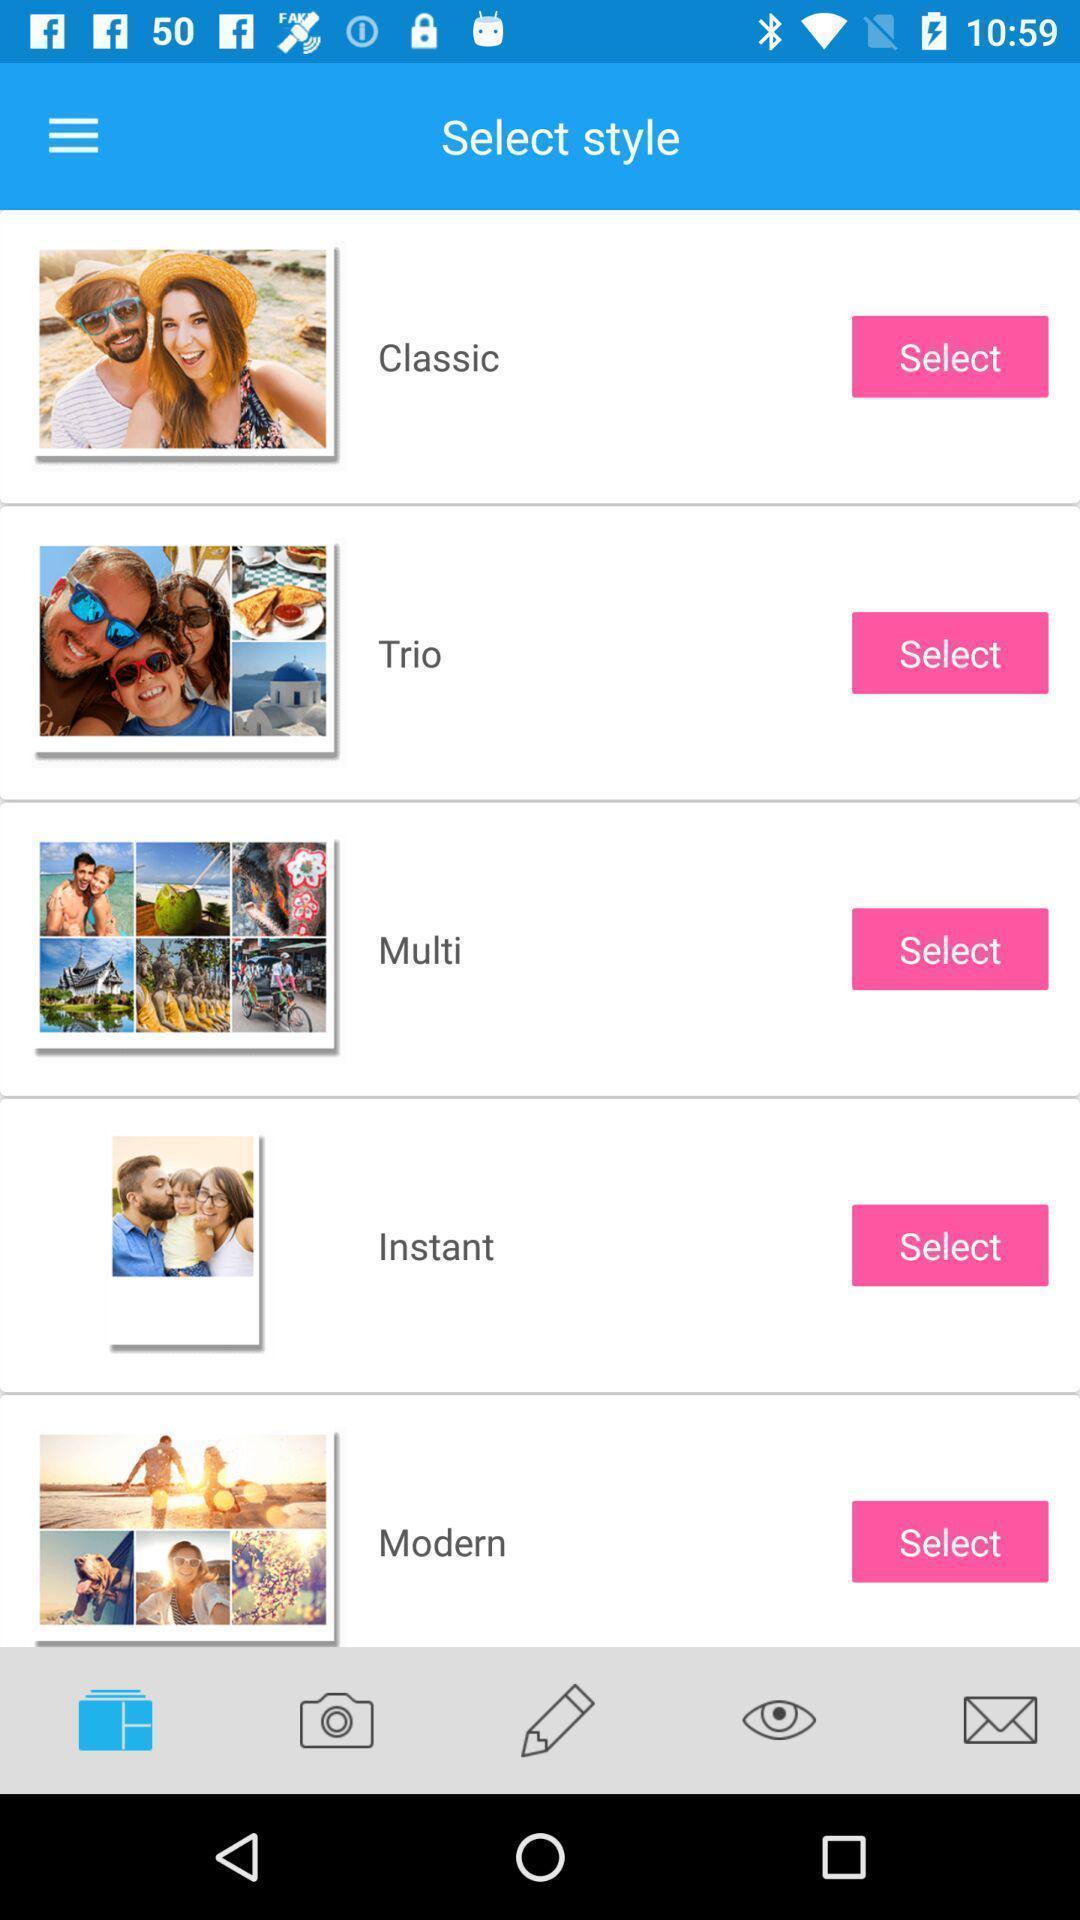Summarize the information in this screenshot. Screen page displaying to select various image styles. 